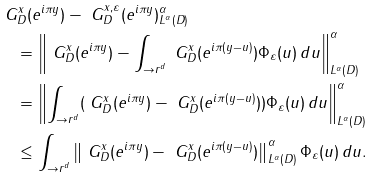Convert formula to latex. <formula><loc_0><loc_0><loc_500><loc_500>& \| \ G _ { D } ^ { x } ( e ^ { i \pi y } ) - \ G _ { D } ^ { x , \varepsilon } ( e ^ { i \pi y } ) \| _ { L ^ { \alpha } ( D ) } ^ { \alpha } \\ & \quad = \left \| \ G _ { D } ^ { x } ( e ^ { i \pi y } ) - \int _ { \to r ^ { d } } \ G _ { D } ^ { x } ( e ^ { i \pi ( y - u ) } ) \Phi _ { \varepsilon } ( u ) \, d u \right \| _ { L ^ { \alpha } ( D ) } ^ { \alpha } \\ & \quad = \left \| \int _ { \to r ^ { d } } ( \ G _ { D } ^ { x } ( e ^ { i \pi y } ) - \ G _ { D } ^ { x } ( e ^ { i \pi ( y - u ) } ) ) \Phi _ { \varepsilon } ( u ) \, d u \right \| _ { L ^ { \alpha } ( D ) } ^ { \alpha } \\ & \quad \leq \int _ { \to r ^ { d } } \left \| \ G _ { D } ^ { x } ( e ^ { i \pi y } ) - \ G _ { D } ^ { x } ( e ^ { i \pi ( y - u ) } ) \right \| _ { L ^ { \alpha } ( D ) } ^ { \alpha } \Phi _ { \varepsilon } ( u ) \, d u .</formula> 